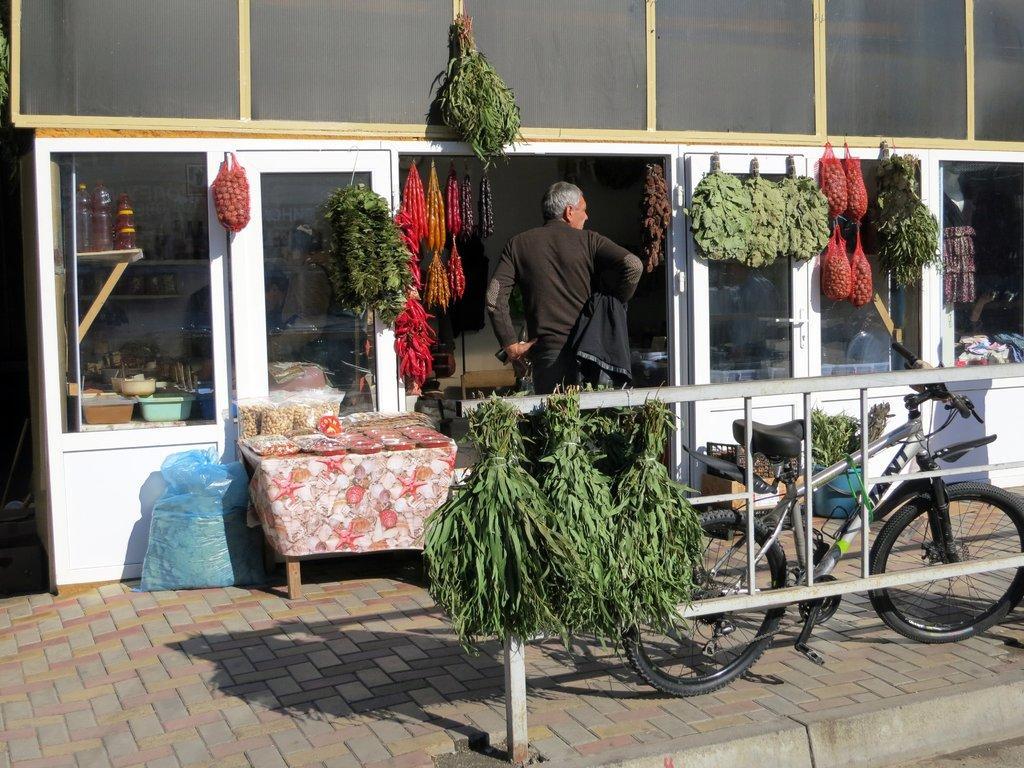Please provide a concise description of this image. In the center of the image there is a man standing at the door. On the right side of the image we can see vegetables, windows, cycle and clothes. On the left side of the image we can see table, bottles, windows and some leaves. In the foreground we can see vegetables and fencing. 